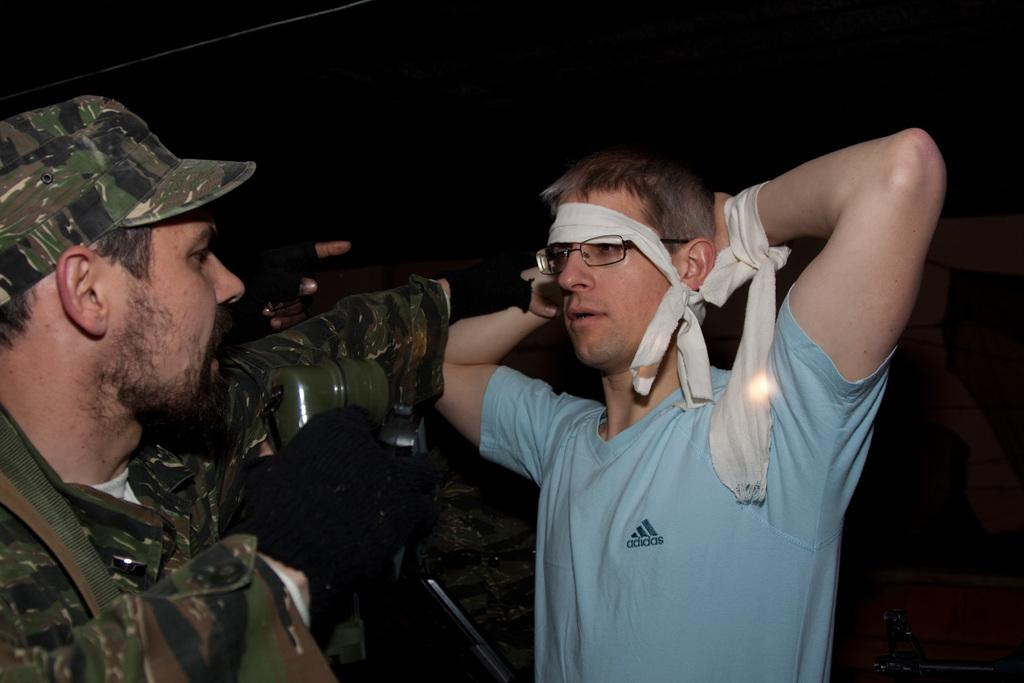How many people are in the image? There are two men in the image. Where are the men located in the image? The men are standing in the foreground area of the image. What color is the background of the image? The background of the image is black. Can you see any waves or a lake in the image? There is no reference to waves or a lake in the image; it only features two men standing in the foreground with a black background. 